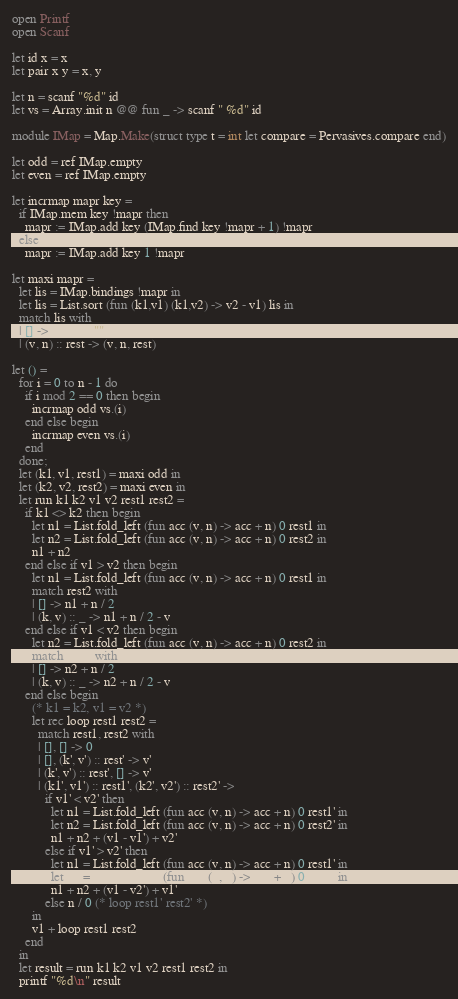Convert code to text. <code><loc_0><loc_0><loc_500><loc_500><_OCaml_>open Printf
open Scanf

let id x = x
let pair x y = x, y

let n = scanf "%d" id
let vs = Array.init n @@ fun _ -> scanf " %d" id

module IMap = Map.Make(struct type t = int let compare = Pervasives.compare end)

let odd = ref IMap.empty
let even = ref IMap.empty

let incrmap mapr key =
  if IMap.mem key !mapr then
    mapr := IMap.add key (IMap.find key !mapr + 1) !mapr
  else
    mapr := IMap.add key 1 !mapr

let maxi mapr =
  let lis = IMap.bindings !mapr in
  let lis = List.sort (fun (k1,v1) (k1,v2) -> v2 - v1) lis in
  match lis with
  | [] -> failwith ""
  | (v, n) :: rest -> (v, n, rest)

let () =
  for i = 0 to n - 1 do
    if i mod 2 == 0 then begin
      incrmap odd vs.(i)
    end else begin
      incrmap even vs.(i)
    end
  done;
  let (k1, v1, rest1) = maxi odd in
  let (k2, v2, rest2) = maxi even in
  let run k1 k2 v1 v2 rest1 rest2 =
    if k1 <> k2 then begin
      let n1 = List.fold_left (fun acc (v, n) -> acc + n) 0 rest1 in
      let n2 = List.fold_left (fun acc (v, n) -> acc + n) 0 rest2 in
      n1 + n2
    end else if v1 > v2 then begin
      let n1 = List.fold_left (fun acc (v, n) -> acc + n) 0 rest1 in
      match rest2 with
      | [] -> n1 + n / 2
      | (k, v) :: _ -> n1 + n / 2 - v
    end else if v1 < v2 then begin
      let n2 = List.fold_left (fun acc (v, n) -> acc + n) 0 rest2 in
      match rest1 with
      | [] -> n2 + n / 2
      | (k, v) :: _ -> n2 + n / 2 - v 
    end else begin
      (* k1 = k2, v1 = v2 *)
      let rec loop rest1 rest2 =
        match rest1, rest2 with
        | [], [] -> 0
        | [], (k', v') :: rest' -> v'
        | (k', v') :: rest', [] -> v'
        | (k1', v1') :: rest1', (k2', v2') :: rest2' ->
          if v1' < v2' then
            let n1 = List.fold_left (fun acc (v, n) -> acc + n) 0 rest1' in
            let n2 = List.fold_left (fun acc (v, n) -> acc + n) 0 rest2' in
            n1 + n2 + (v1 - v1') + v2'
          else if v1' > v2' then
            let n1 = List.fold_left (fun acc (v, n) -> acc + n) 0 rest1' in
            let n2 = List.fold_left (fun acc (v, n) -> acc + n) 0 rest2' in
            n1 + n2 + (v1 - v2') + v1' 
          else n / 0 (* loop rest1' rest2' *)
      in
      v1 + loop rest1 rest2
    end
  in
  let result = run k1 k2 v1 v2 rest1 rest2 in
  printf "%d\n" result
</code> 